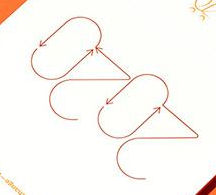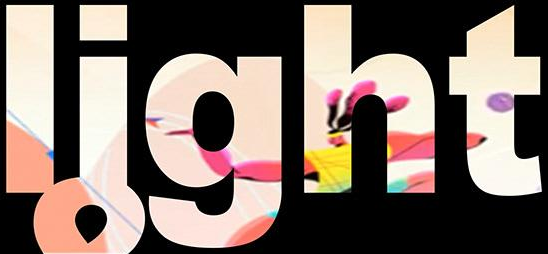What words can you see in these images in sequence, separated by a semicolon? 2020; light 